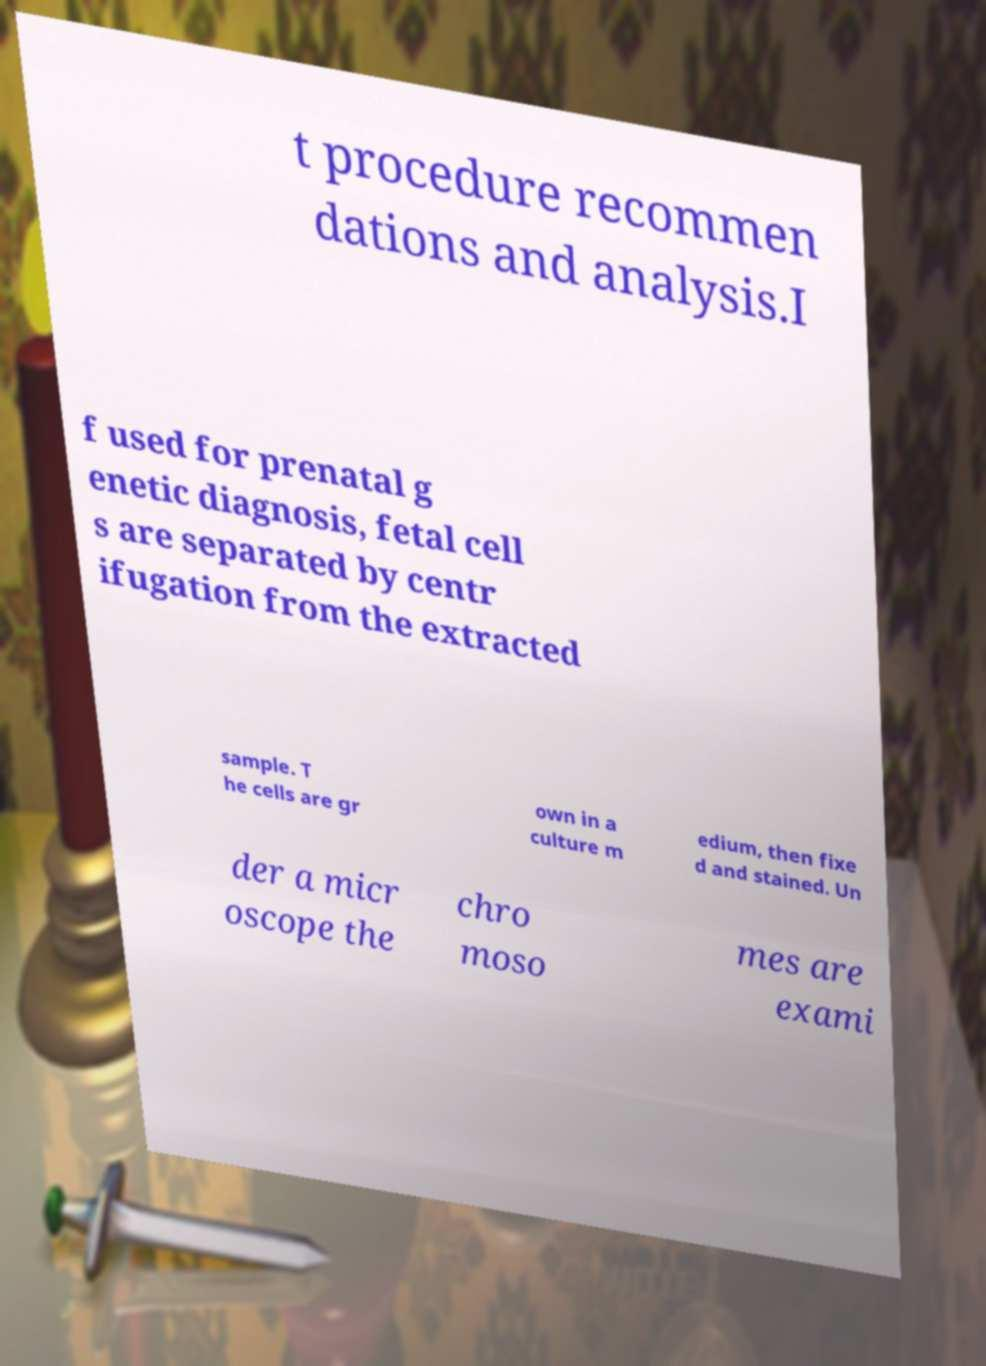Please read and relay the text visible in this image. What does it say? t procedure recommen dations and analysis.I f used for prenatal g enetic diagnosis, fetal cell s are separated by centr ifugation from the extracted sample. T he cells are gr own in a culture m edium, then fixe d and stained. Un der a micr oscope the chro moso mes are exami 